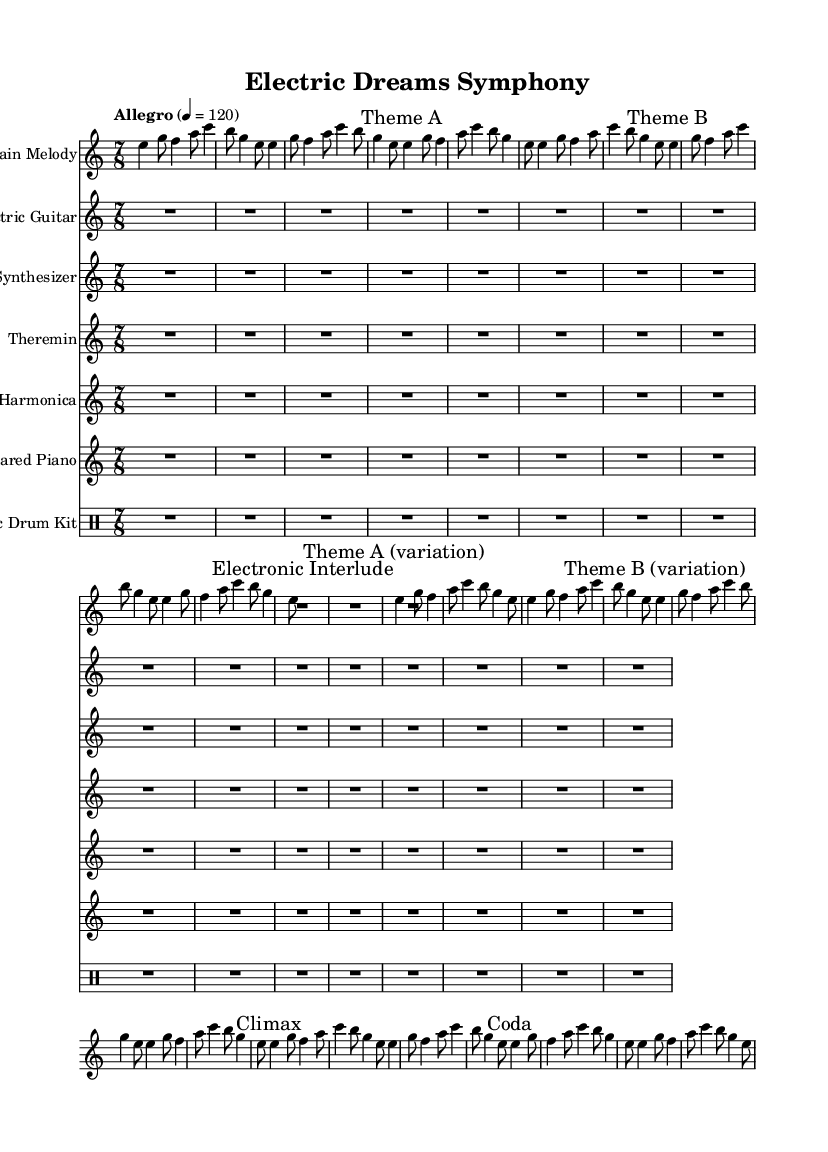What is the time signature of this music? The time signature is indicated at the beginning of the score, showing 7/8, which means there are seven beats in each measure with an eighth note receiving one beat.
Answer: 7/8 What is the tempo marking of this symphony? The tempo marking is stated in the score as "Allegro" and gives a specific metronome marking of 120 beats per minute, indicating a fast and lively tempo.
Answer: Allegro, 120 How many main melody phrases are there before the Electronic Interlude? By counting the measures in the main melody section, there are eight measures before the Electronic Interlude, which is indicated explicitly with a label in the score.
Answer: 8 What types of unconventional instruments are included in this symphony? The symphony features electronic instruments and unconventional instruments, specifically listing the theremin and glass harmonica among the standard instruments in a symphony orchestra, which are not typically used in classical symphonies.
Answer: Theremin, Glass Harmonica How many variations of Theme A are present? The score indicates one clear variation of Theme A that follows the original theme before transitioning to Theme B, signified by the labeling "Theme A (variation)" in the score.
Answer: 1 